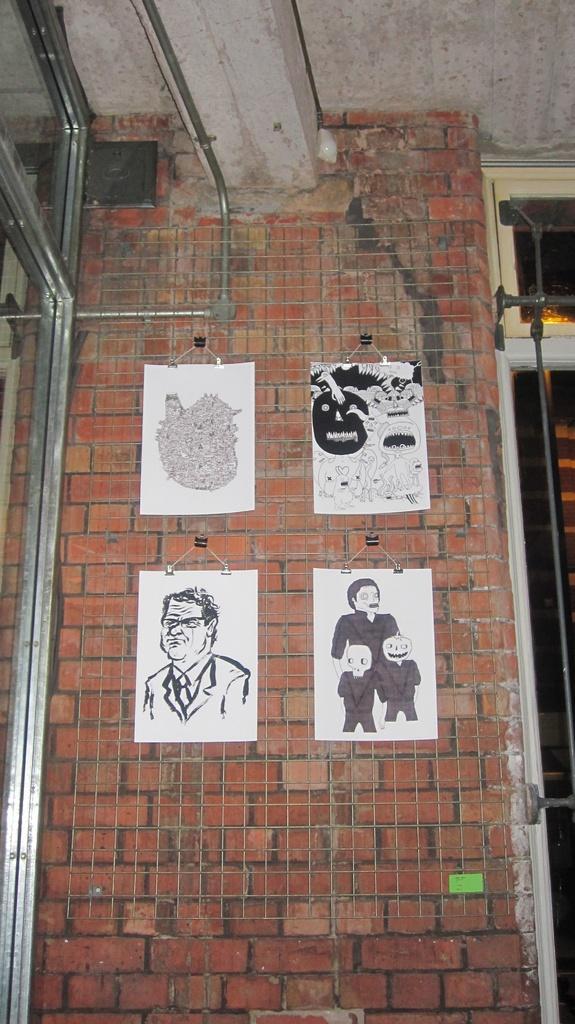Could you give a brief overview of what you see in this image? In this picture I can see the wall in front, on which there are white papers and I see the depiction of few persons and other things on it and on the left of this image I see the rods. 